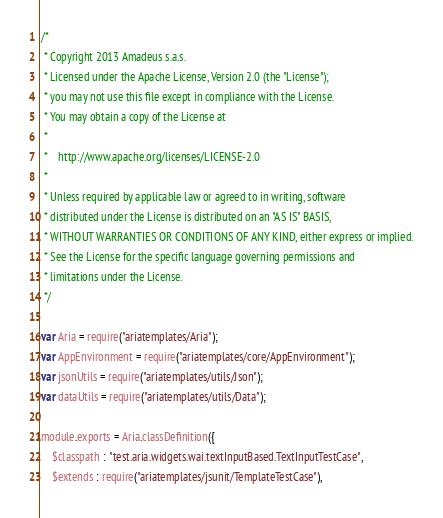Convert code to text. <code><loc_0><loc_0><loc_500><loc_500><_JavaScript_>/*
 * Copyright 2013 Amadeus s.a.s.
 * Licensed under the Apache License, Version 2.0 (the "License");
 * you may not use this file except in compliance with the License.
 * You may obtain a copy of the License at
 *
 *    http://www.apache.org/licenses/LICENSE-2.0
 *
 * Unless required by applicable law or agreed to in writing, software
 * distributed under the License is distributed on an "AS IS" BASIS,
 * WITHOUT WARRANTIES OR CONDITIONS OF ANY KIND, either express or implied.
 * See the License for the specific language governing permissions and
 * limitations under the License.
 */

var Aria = require("ariatemplates/Aria");
var AppEnvironment = require("ariatemplates/core/AppEnvironment");
var jsonUtils = require("ariatemplates/utils/Json");
var dataUtils = require("ariatemplates/utils/Data");

module.exports = Aria.classDefinition({
    $classpath : "test.aria.widgets.wai.textInputBased.TextInputTestCase",
    $extends : require("ariatemplates/jsunit/TemplateTestCase"),</code> 